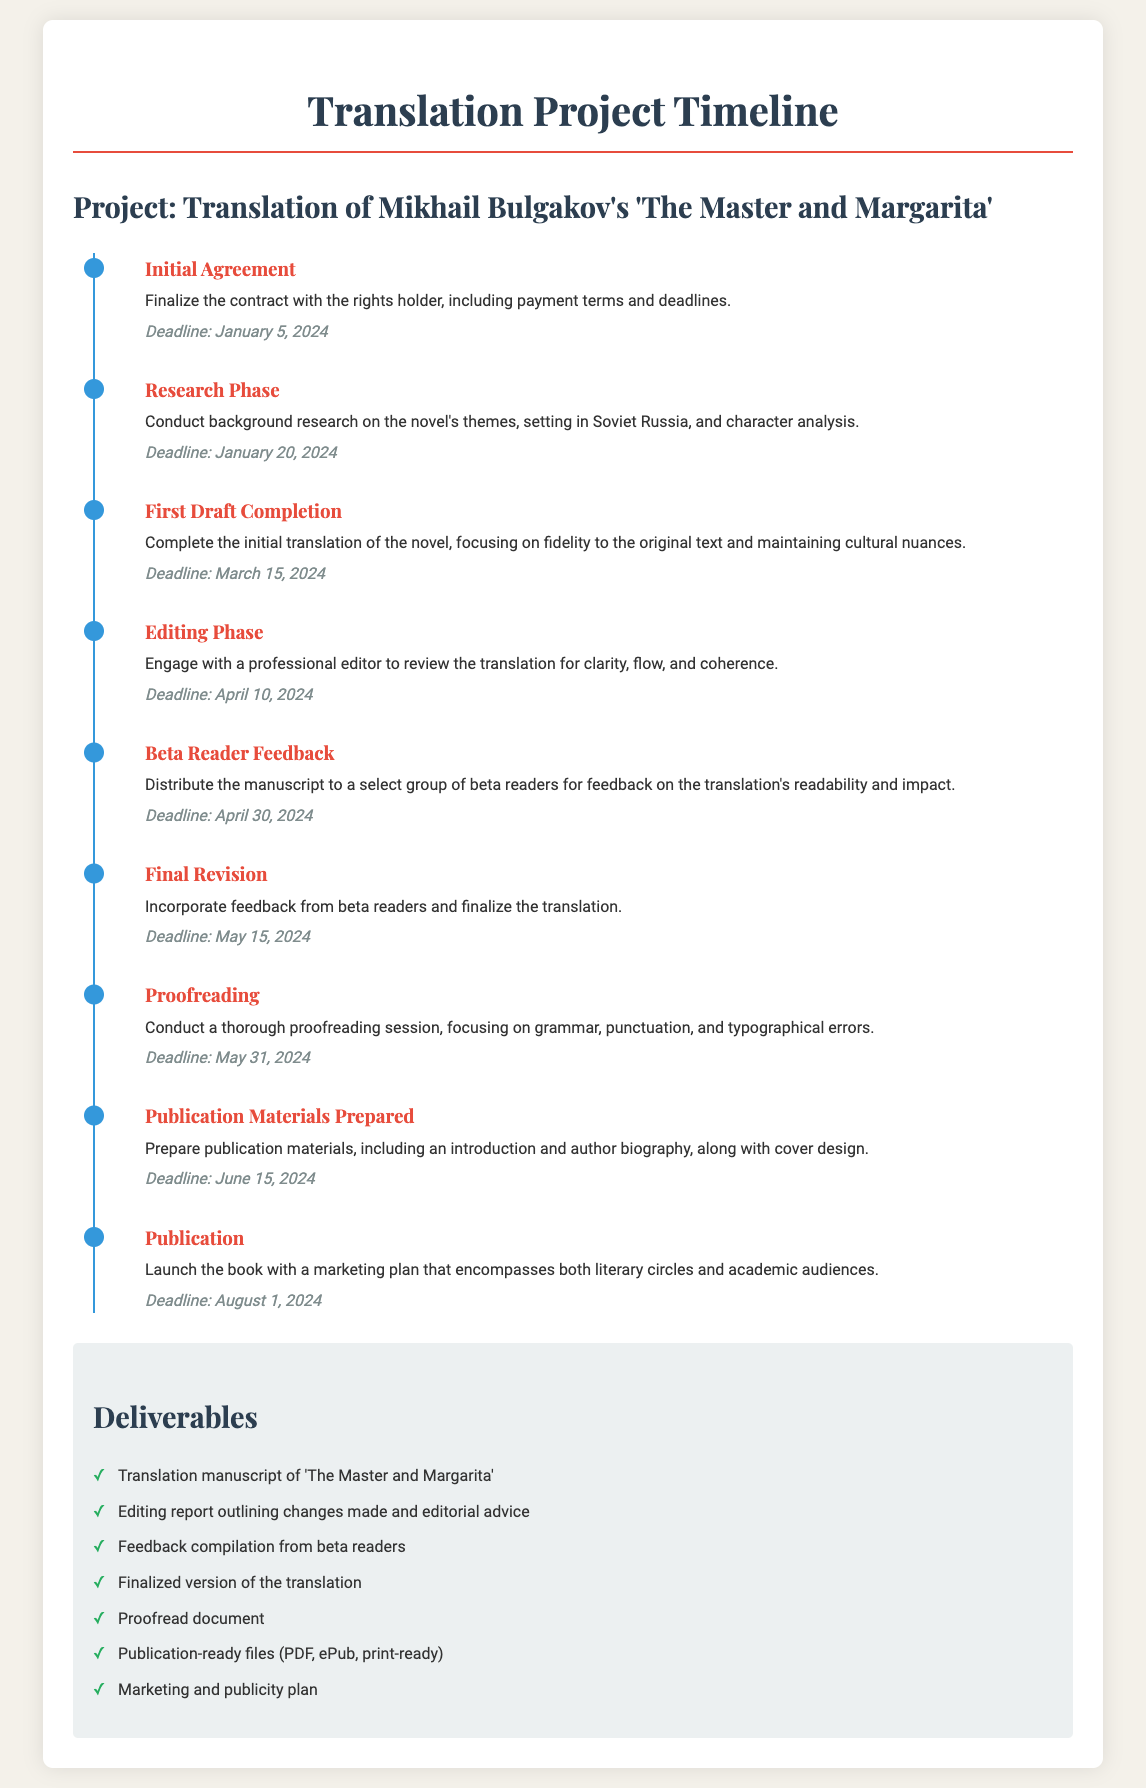What is the title of the novel being translated? The title of the novel is mentioned in the project header, which is 'The Master and Margarita.'
Answer: The Master and Margarita When is the deadline for the Initial Agreement? The deadline for the Initial Agreement is stated in the timeline section of the document.
Answer: January 5, 2024 What phase comes after the First Draft Completion? The timeline specifies that the phase following the First Draft Completion is the Editing Phase.
Answer: Editing Phase How many deliverables are listed in the document? The number of deliverables can be counted in the "Deliverables" section of the document.
Answer: Seven What is the deadline for Proofreading? The deadline for Proofreading is clearly marked in the timeline.
Answer: May 31, 2024 Who should be engaged during the Editing Phase? The document notes to engage with a professional editor during the Editing Phase.
Answer: Professional editor What is a key focus during the First Draft Completion? The key focus during the First Draft Completion is maintaining fidelity to the original text and cultural nuances.
Answer: Fidelity to original text What should be included in the publication materials? The publication materials should include an introduction and author biography, along with cover design.
Answer: Introduction and author biography What feedback method is planned after the translation is completed? The planned feedback method after the translation is completed is distributing the manuscript to beta readers.
Answer: Beta readers 